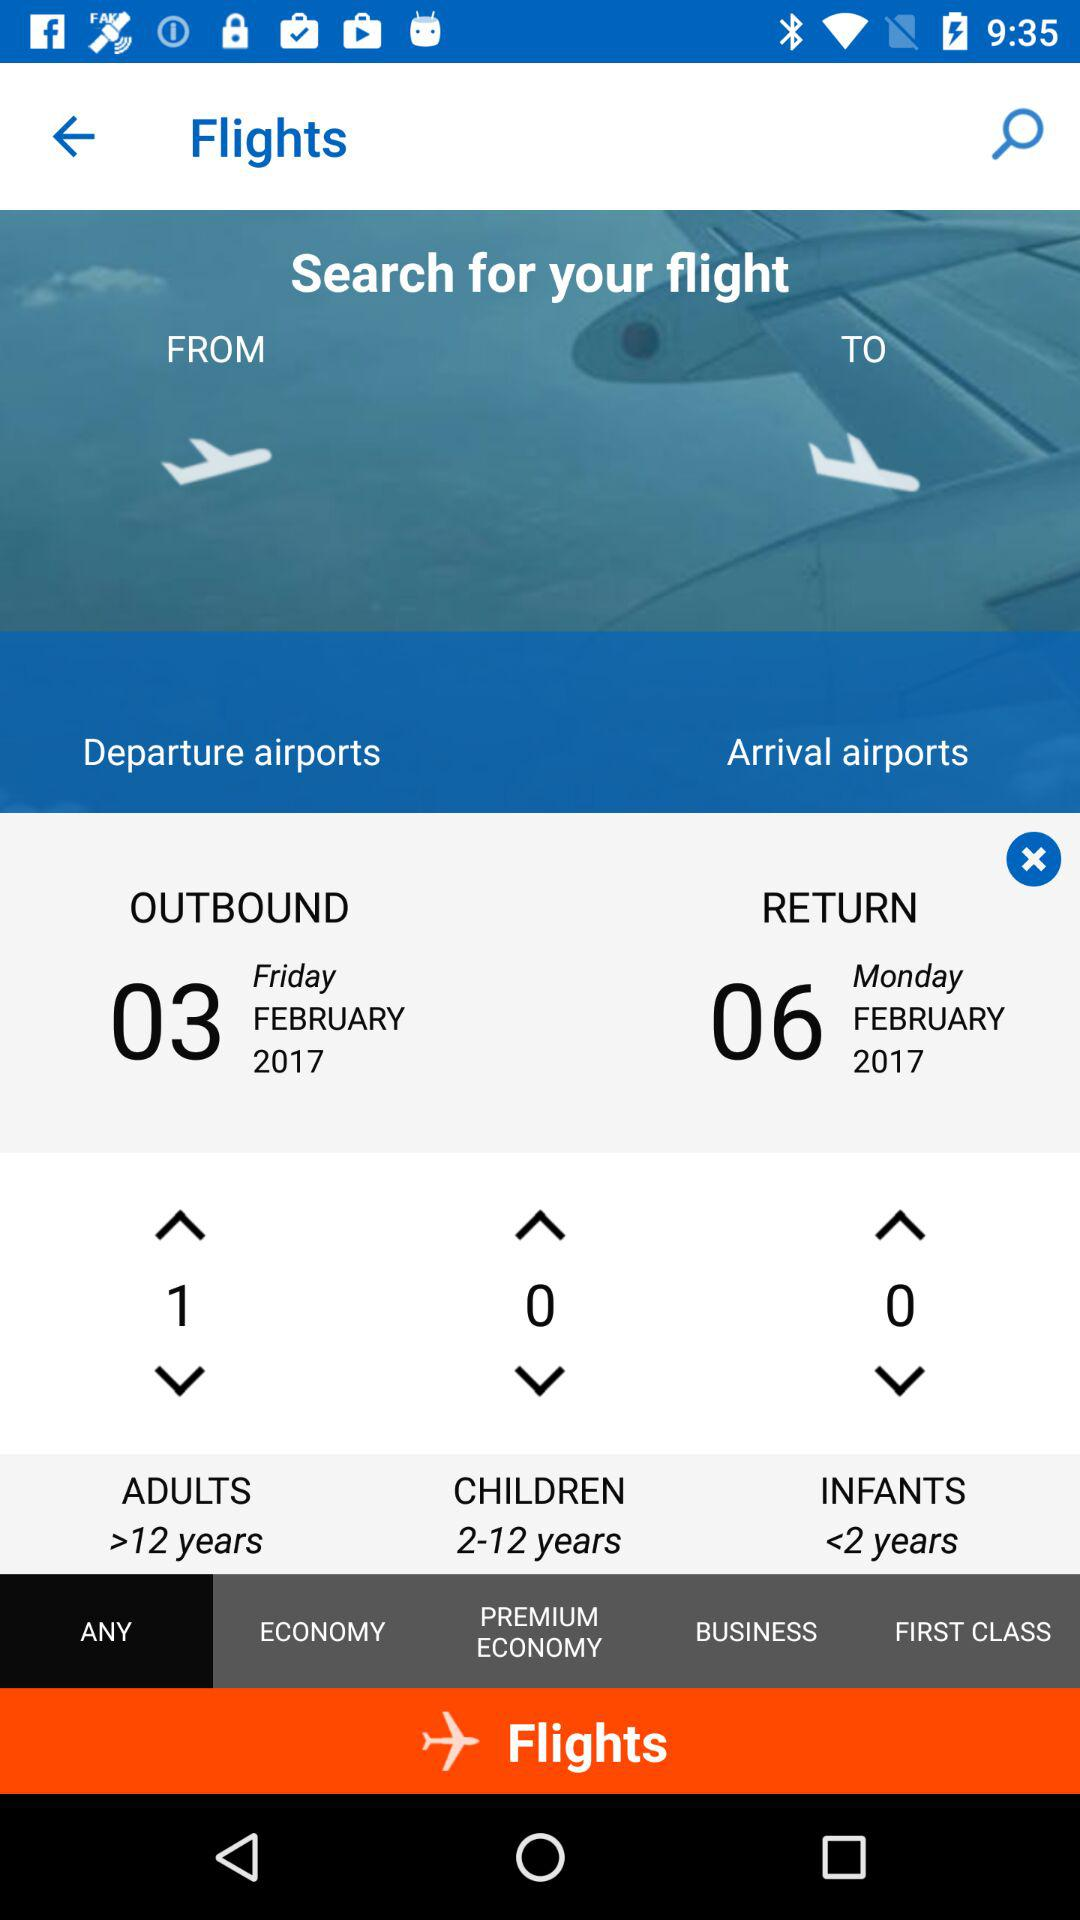What is the age limit for children? The age limit for children is from 2 to 12 years. 